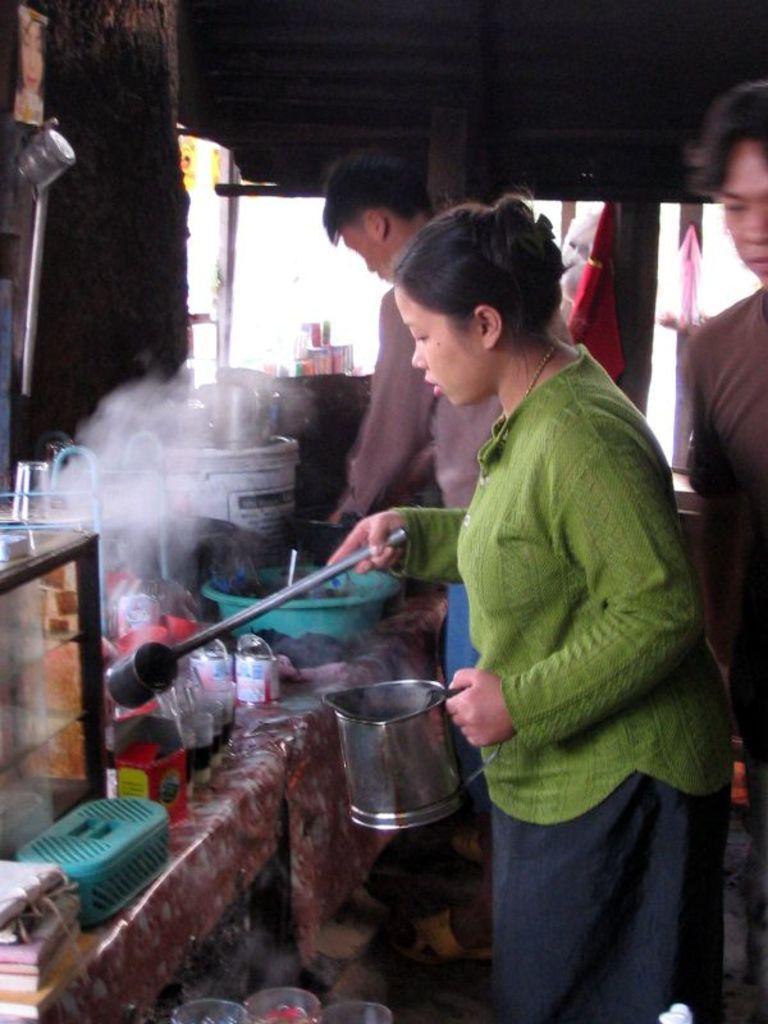Can you describe this image briefly? In this picture I can see few people standing and I can see a woman holding a steel Jug and a metal serving spoon in her hand and I can see few bottles and a plastic tub and a box and few books. 